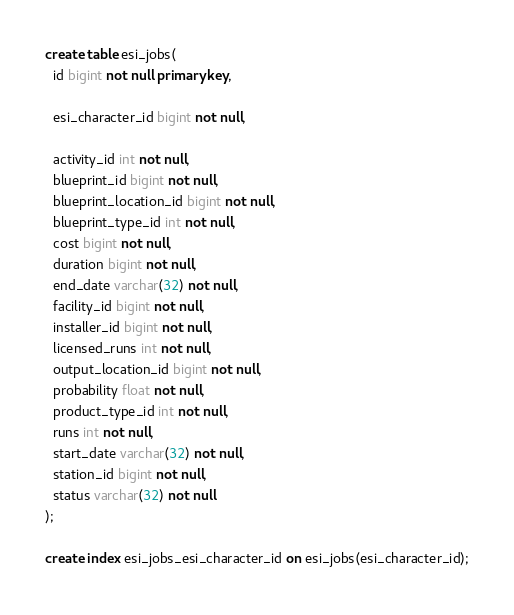Convert code to text. <code><loc_0><loc_0><loc_500><loc_500><_SQL_>create table esi_jobs(
  id bigint not null primary key,

  esi_character_id bigint not null,

  activity_id int not null,
  blueprint_id bigint not null,
  blueprint_location_id bigint not null,
  blueprint_type_id int not null,
  cost bigint not null,
  duration bigint not null,
  end_date varchar(32) not null,
  facility_id bigint not null,
  installer_id bigint not null,
  licensed_runs int not null,
  output_location_id bigint not null,
  probability float not null,
  product_type_id int not null,
  runs int not null,
  start_date varchar(32) not null,
  station_id bigint not null,
  status varchar(32) not null
);

create index esi_jobs_esi_character_id on esi_jobs(esi_character_id);
</code> 